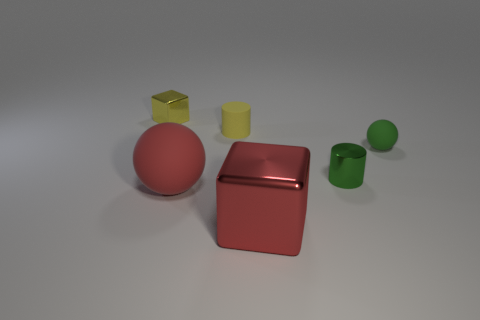Add 3 yellow cylinders. How many objects exist? 9 Subtract all cylinders. How many objects are left? 4 Subtract all green metallic spheres. Subtract all matte cylinders. How many objects are left? 5 Add 6 small green metallic objects. How many small green metallic objects are left? 7 Add 2 tiny brown matte things. How many tiny brown matte things exist? 2 Subtract 0 cyan blocks. How many objects are left? 6 